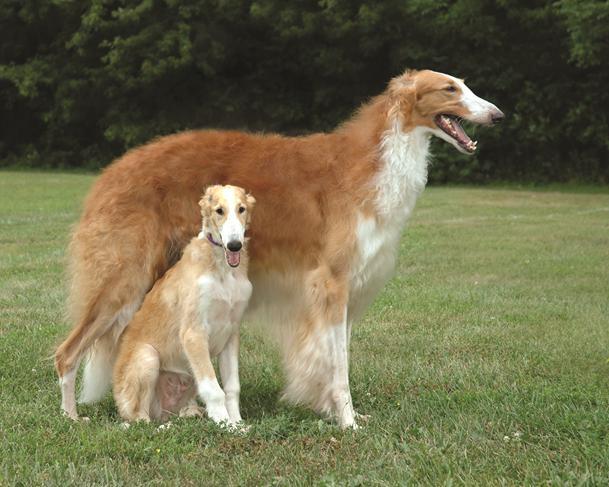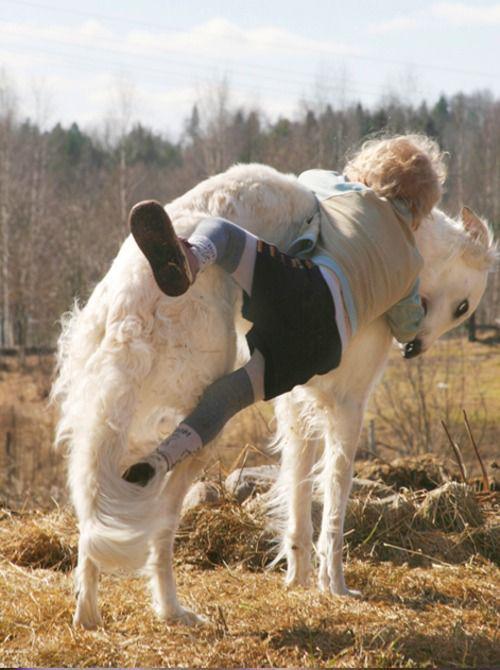The first image is the image on the left, the second image is the image on the right. Assess this claim about the two images: "There are two dogs". Correct or not? Answer yes or no. No. 